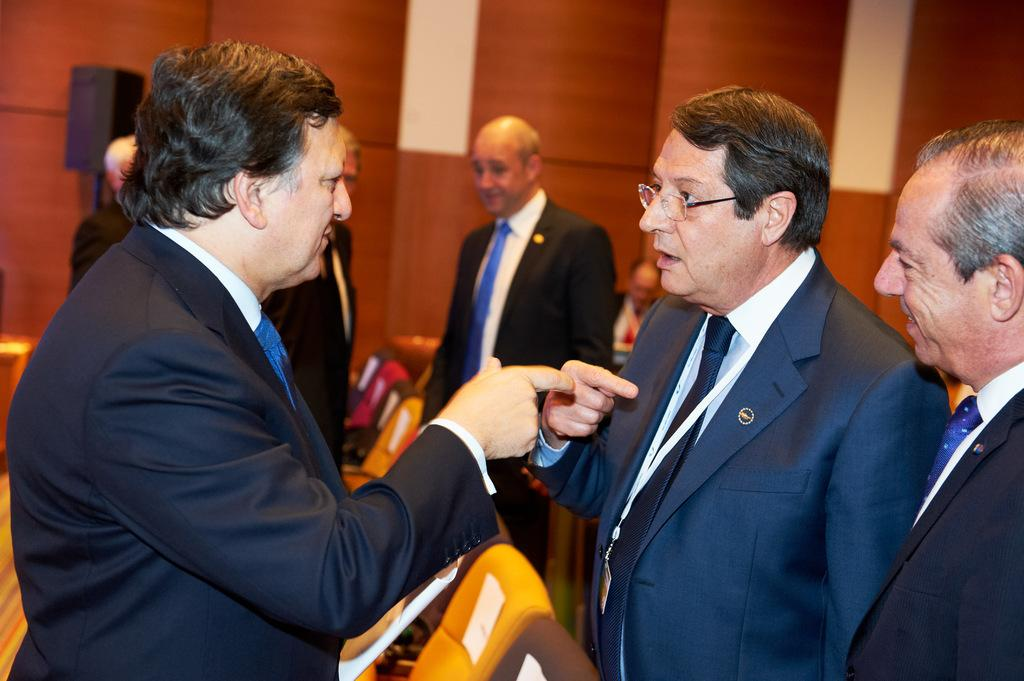How many people are in the image? There are persons in the image, but the exact number is not specified. What is behind the persons in the image? The persons are in front of a wall. What are the persons wearing in the image? The persons are wearing clothes. What can be seen at the bottom of the image? There are seats at the bottom of the image. What type of brush can be seen in the aftermath of the wave in the image? There is no wave, brush, or aftermath present in the image. 